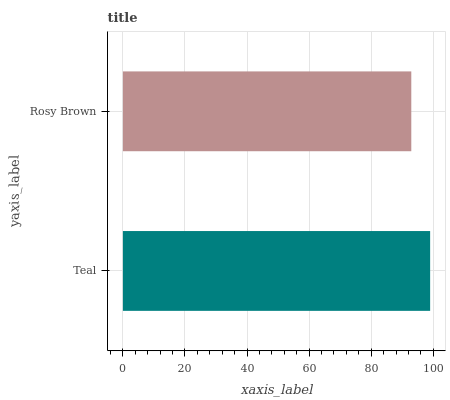Is Rosy Brown the minimum?
Answer yes or no. Yes. Is Teal the maximum?
Answer yes or no. Yes. Is Rosy Brown the maximum?
Answer yes or no. No. Is Teal greater than Rosy Brown?
Answer yes or no. Yes. Is Rosy Brown less than Teal?
Answer yes or no. Yes. Is Rosy Brown greater than Teal?
Answer yes or no. No. Is Teal less than Rosy Brown?
Answer yes or no. No. Is Teal the high median?
Answer yes or no. Yes. Is Rosy Brown the low median?
Answer yes or no. Yes. Is Rosy Brown the high median?
Answer yes or no. No. Is Teal the low median?
Answer yes or no. No. 